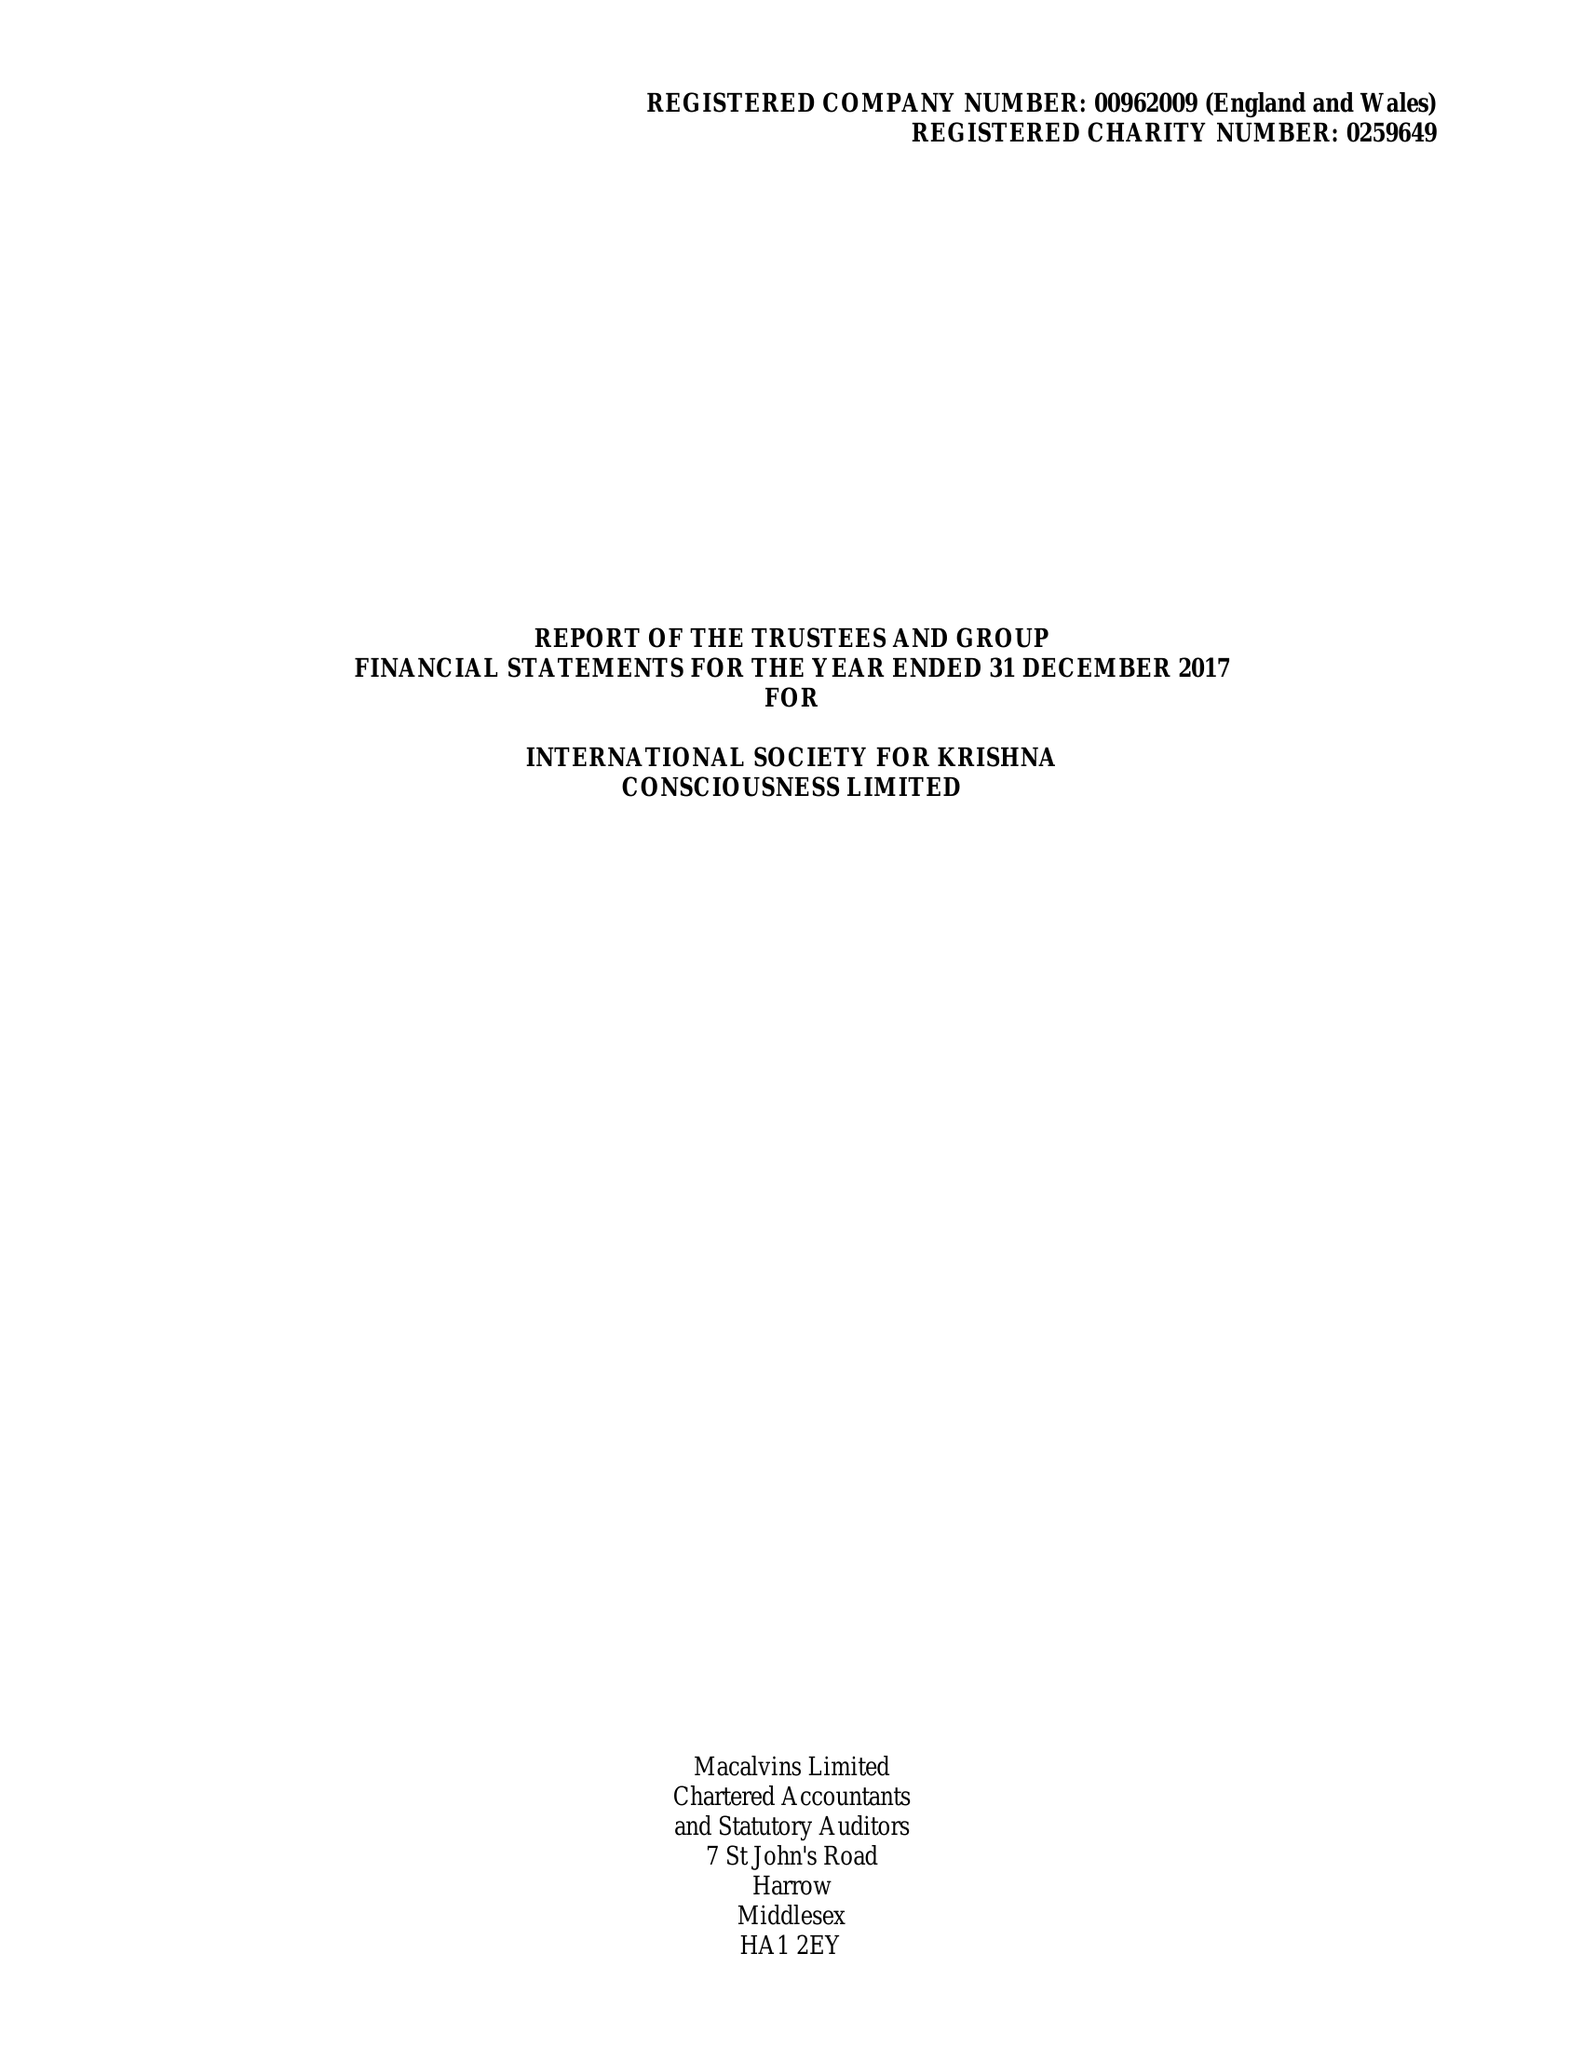What is the value for the income_annually_in_british_pounds?
Answer the question using a single word or phrase. 10443919.00 